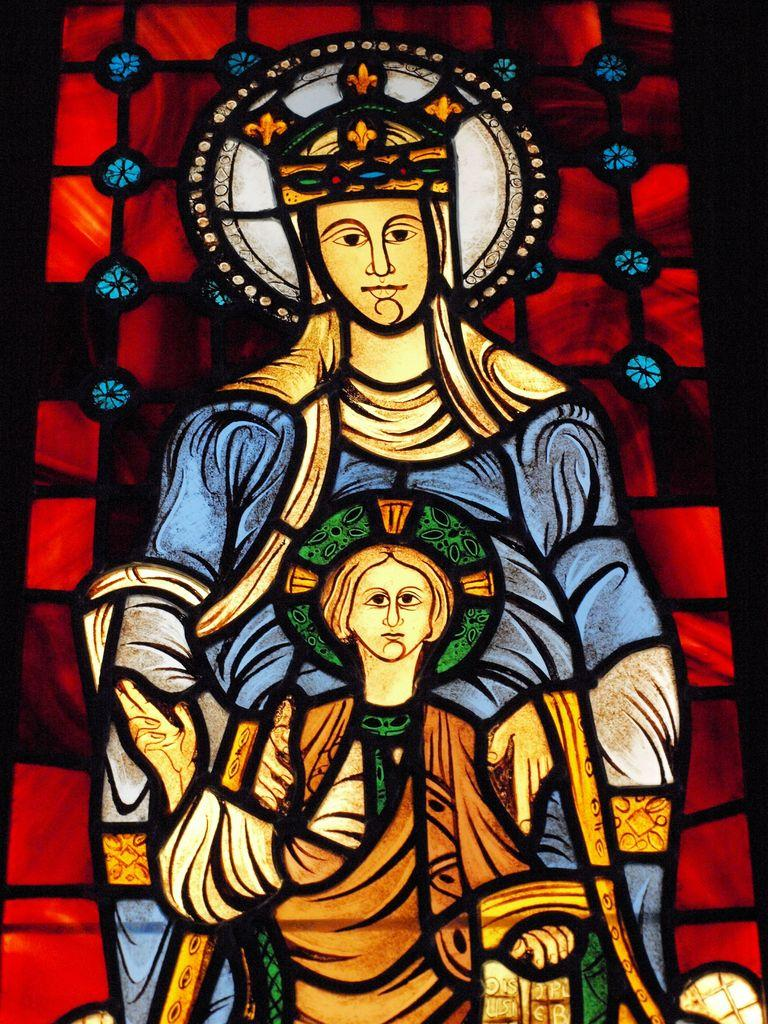What is depicted in the paintings in the image? There are paintings of two persons in the image. What colors are present in the background of the image? The background of the image contains red and blue colors. What type of game is being played in the image? There is no game being played in the image; it features paintings of two persons with a red and blue background. What type of writing can be seen on the paintings? There is no writing visible on the paintings in the image. 